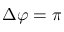Convert formula to latex. <formula><loc_0><loc_0><loc_500><loc_500>\Delta \varphi = \pi</formula> 